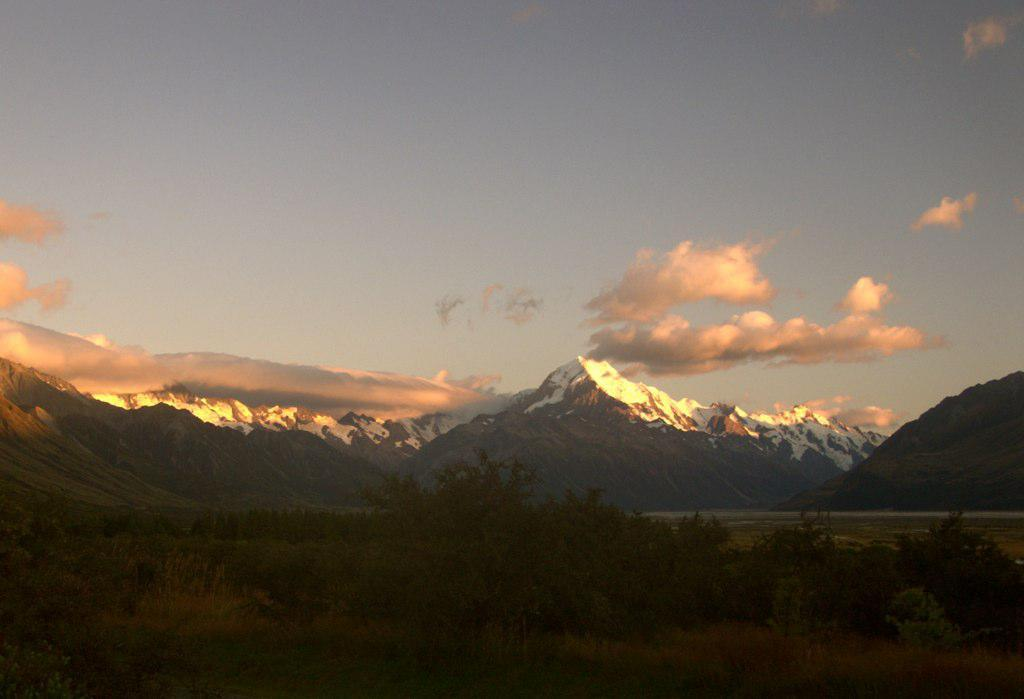What type of vegetation is present at the bottom of the image? There are many plants at the bottom of the image. What geographical feature is located in the middle of the image? There are mountains in the middle of the image. What is the condition of the mountains in the image? The mountains have snow on them. What is visible at the top of the image? The sky is visible at the top of the image. What type of hair can be seen on the plants in the image? There is no hair present on the plants in the image; they are simply vegetation. How does the taste of the mountains compare to the taste of the plants in the image? There is no taste associated with the mountains or plants in the image, as they are not edible. 